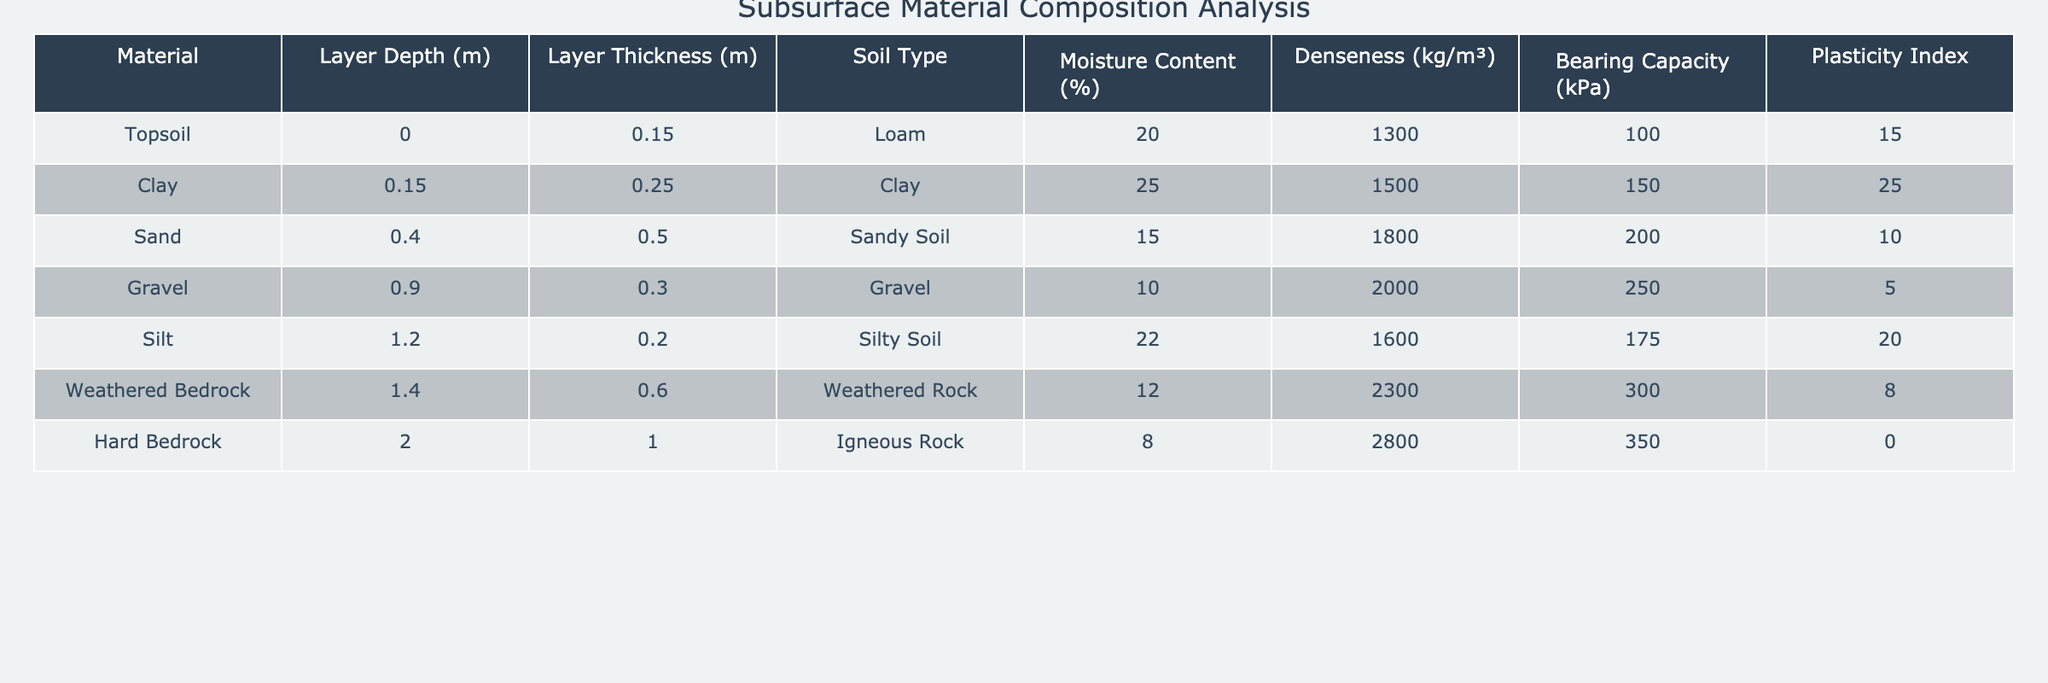What is the moisture content of the Clay layer? According to the table, the moisture content for the Clay layer is listed as 25%.
Answer: 25% What is the bearing capacity of the Hard Bedrock? The table shows that the bearing capacity of the Hard Bedrock is 350 kPa.
Answer: 350 kPa Which soil type has the highest denseness? The Hard Bedrock has a denseness of 2800 kg/m³, which is higher than the other materials listed.
Answer: Hard Bedrock What is the total thickness of all layers combined? Adding the layer thickness of each material (0.15 + 0.25 + 0.50 + 0.30 + 0.20 + 0.60 + 1.00) gives a total thickness of 2.10m.
Answer: 2.10m Which soil type has the lowest plasticity index? The Hard Bedrock has a plasticity index of 0, which is the lowest among the materials.
Answer: Hard Bedrock What is the average bearing capacity of the top three layers? To find the average bearing capacity, sum the bearing capacity values (100 + 150 + 200 = 450) and divide by 3, resulting in 150 kPa.
Answer: 150 kPa Is the moisture content of Sand lower than that of Clay? The moisture content of Sand is 15%, while that of Clay is 25%. Hence, the statement is true.
Answer: Yes Which layer has a layer thickness greater than 0.5m? The Weathered Bedrock and Hard Bedrock layers both have thicknesses greater than 0.5m (0.60m and 1.00m respectively).
Answer: Weathered Bedrock, Hard Bedrock What is the difference in denseness between the material with the highest and the lowest denseness? The highest denseness is that of Hard Bedrock at 2800 kg/m³ and the lowest is Topsoil at 1300 kg/m³. The difference is 2800 - 1300 = 1500 kg/m³.
Answer: 1500 kg/m³ Does any layer show a moisture content above 20%? Yes, both the Clay (25%) and Silt (22%) layers have moisture contents above 20%.
Answer: Yes 